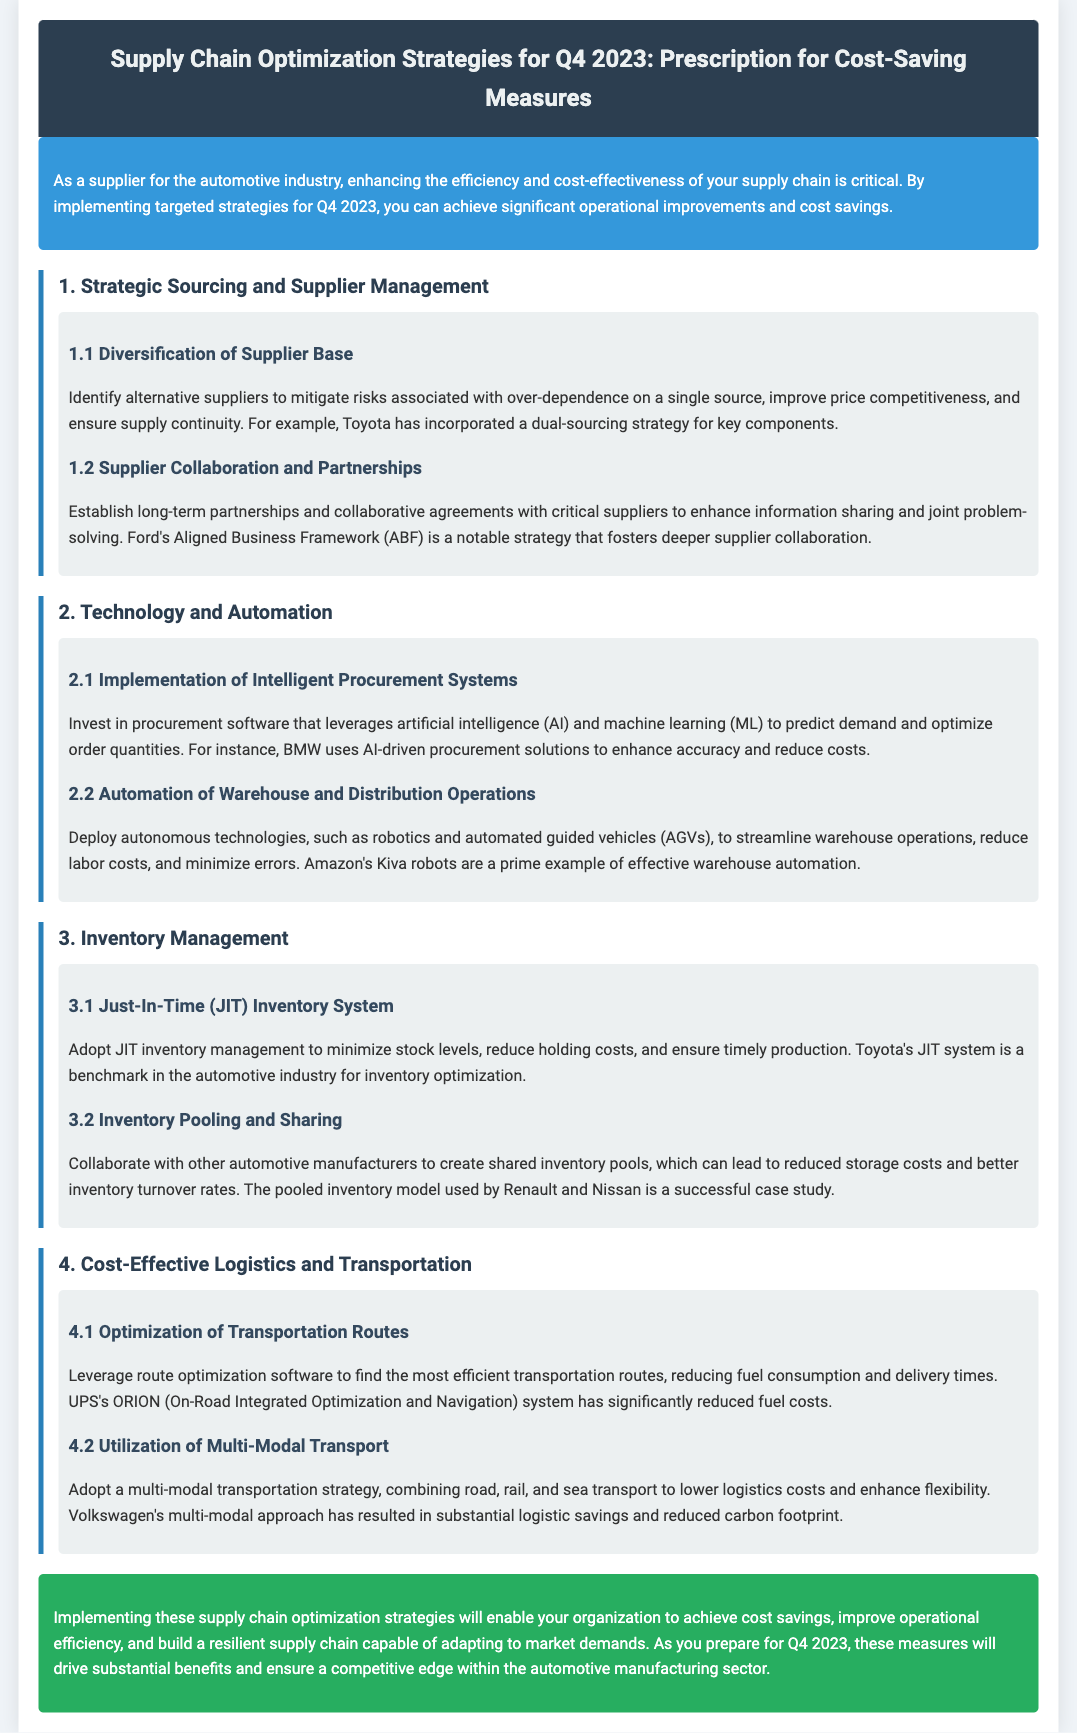What is the title of the document? The title is stated at the top of the document inside the header section.
Answer: Supply Chain Optimization Strategies for Q4 2023: Prescription for Cost-Saving Measures What is a notable strategy used by Ford? This information is found under the supplier collaboration section of the document, showing an example of enhanced partnerships.
Answer: Aligned Business Framework (ABF) Which company uses AI-driven procurement solutions? This is mentioned in the section about technology and automation, highlighting the application of advanced systems.
Answer: BMW What inventory management system is benchmarked in the document? The document specifically references an inventory management technique widely recognized in the industry, providing clarity on its usage.
Answer: Just-In-Time (JIT) Inventory System Which logistics optimization software does UPS utilize? The document provides an example of a system used for reducing costs, located in the logistics and transportation section.
Answer: ORION Name one benefit of diversifying the supplier base. The benefits are discussed in the strategic sourcing section, with emphasis on risk mitigation and competitive pricing.
Answer: Risk mitigation What approach did Volkswagen adopt for transportation? This information includes an example from the logistics section, highlighting a strategy that fosters efficiency.
Answer: Multi-modal transportation strategy How does Toyota minimize stock levels? This concept is presented in the context of effective inventory management techniques.
Answer: Just-In-Time (JIT) Inventory System 